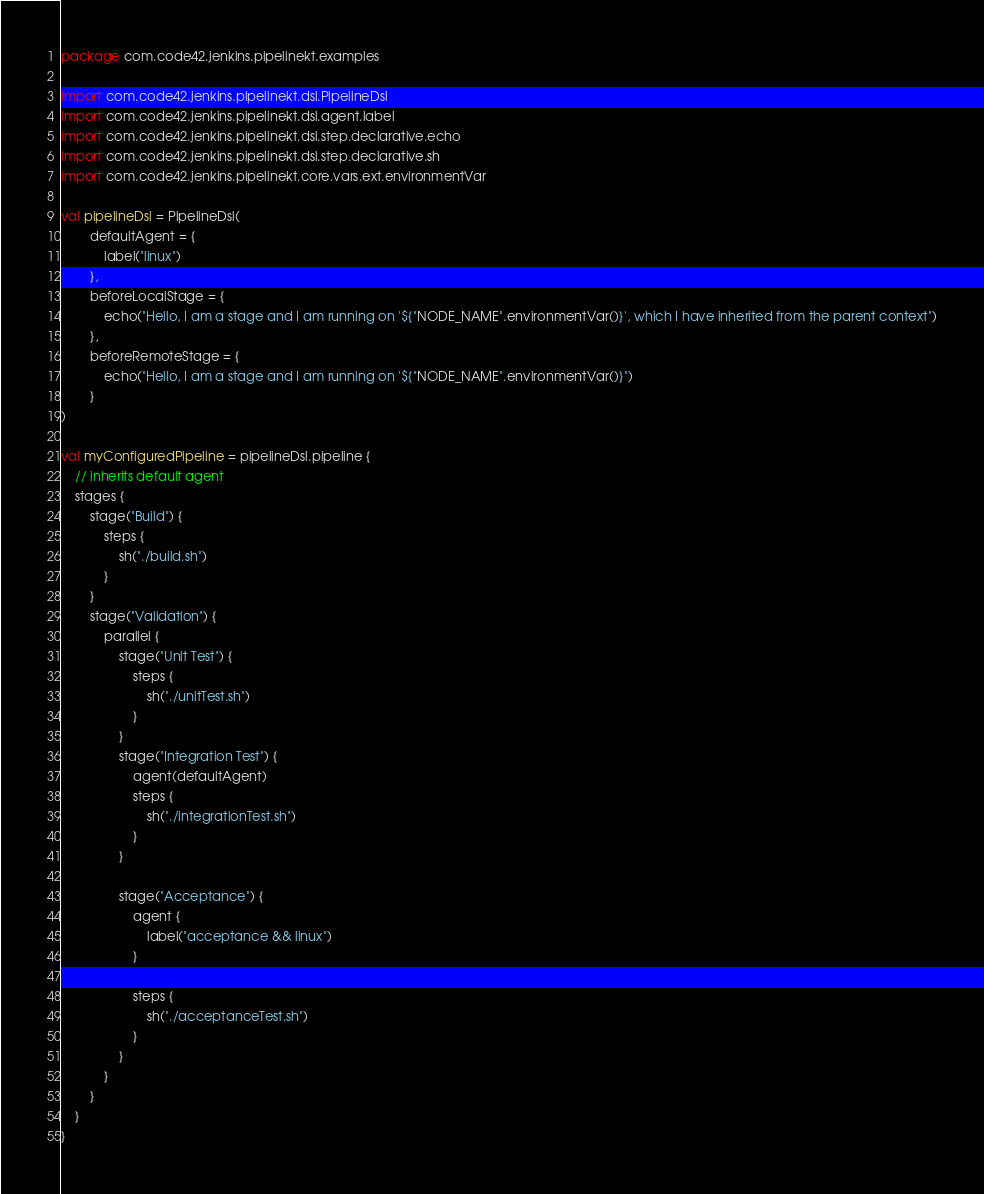Convert code to text. <code><loc_0><loc_0><loc_500><loc_500><_Kotlin_>package com.code42.jenkins.pipelinekt.examples

import com.code42.jenkins.pipelinekt.dsl.PipelineDsl
import com.code42.jenkins.pipelinekt.dsl.agent.label
import com.code42.jenkins.pipelinekt.dsl.step.declarative.echo
import com.code42.jenkins.pipelinekt.dsl.step.declarative.sh
import com.code42.jenkins.pipelinekt.core.vars.ext.environmentVar

val pipelineDsl = PipelineDsl(
        defaultAgent = {
            label("linux")
        },
        beforeLocalStage = {
            echo("Hello, I am a stage and I am running on '${"NODE_NAME".environmentVar()}', which I have inherited from the parent context")
        },
        beforeRemoteStage = {
            echo("Hello, I am a stage and I am running on '${"NODE_NAME".environmentVar()}")
        }
)

val myConfiguredPipeline = pipelineDsl.pipeline {
    // inherits default agent
    stages {
        stage("Build") {
            steps {
                sh("./build.sh")
            }
        }
        stage("Validation") {
            parallel {
                stage("Unit Test") {
                    steps {
                        sh("./unitTest.sh")
                    }
                }
                stage("Integration Test") {
                    agent(defaultAgent)
                    steps {
                        sh("./integrationTest.sh")
                    }
                }

                stage("Acceptance") {
                    agent {
                        label("acceptance && linux")
                    }

                    steps {
                        sh("./acceptanceTest.sh")
                    }
                }
            }
        }
    }
}
</code> 